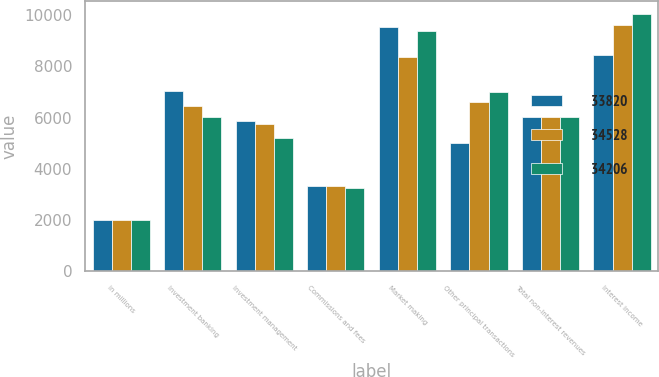Convert chart to OTSL. <chart><loc_0><loc_0><loc_500><loc_500><stacked_bar_chart><ecel><fcel>in millions<fcel>Investment banking<fcel>Investment management<fcel>Commissions and fees<fcel>Market making<fcel>Other principal transactions<fcel>Total non-interest revenues<fcel>Interest income<nl><fcel>33820<fcel>2015<fcel>7027<fcel>5868<fcel>3320<fcel>9523<fcel>5018<fcel>6004<fcel>8452<nl><fcel>34528<fcel>2014<fcel>6464<fcel>5748<fcel>3316<fcel>8365<fcel>6588<fcel>6004<fcel>9604<nl><fcel>34206<fcel>2013<fcel>6004<fcel>5194<fcel>3255<fcel>9368<fcel>6993<fcel>6004<fcel>10060<nl></chart> 